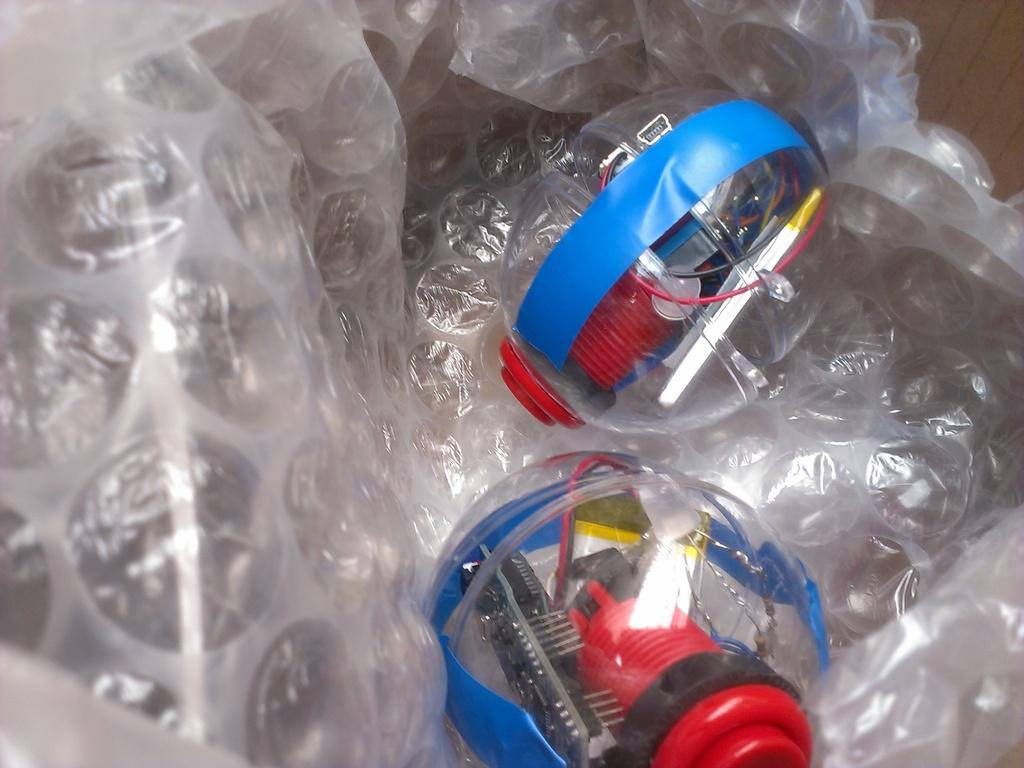How many glass objects are visible in the image? There are two glass objects in the image. What colors are the glass objects? One glass object is blue in color, and the other is red in color. Where are the glass objects placed? The two glass objects are on a transparent cover. What type of lettuce can be seen growing in the wilderness in the image? There is no lettuce or wilderness present in the image; it features two glass objects on a transparent cover. 